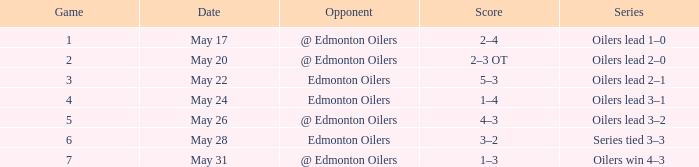Score of 2–3 ot on what date? May 20. 